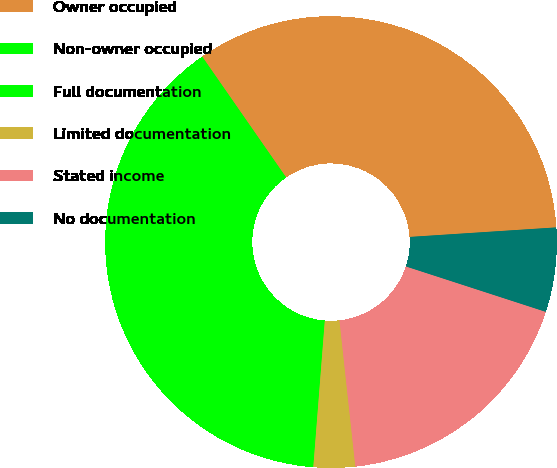Convert chart. <chart><loc_0><loc_0><loc_500><loc_500><pie_chart><fcel>Owner occupied<fcel>Non-owner occupied<fcel>Full documentation<fcel>Limited documentation<fcel>Stated income<fcel>No documentation<nl><fcel>33.63%<fcel>15.21%<fcel>23.88%<fcel>2.97%<fcel>18.28%<fcel>6.03%<nl></chart> 